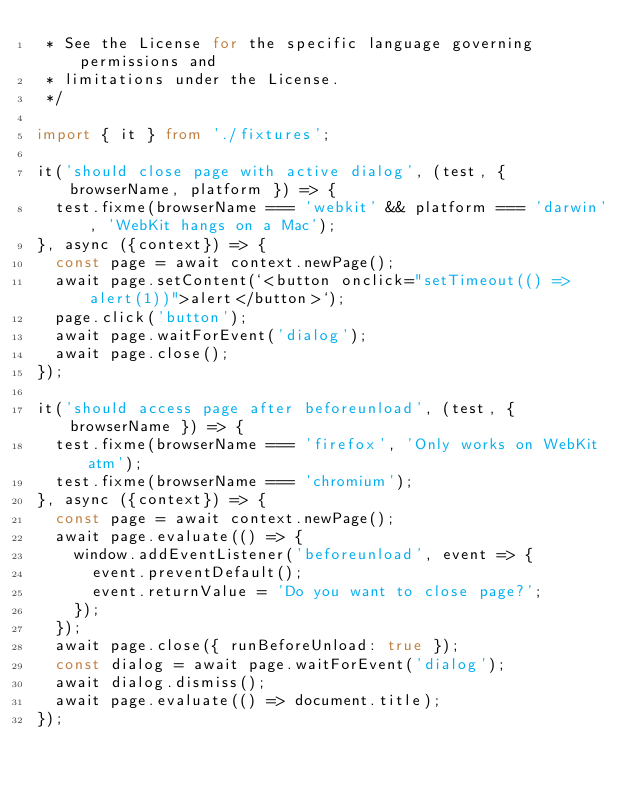Convert code to text. <code><loc_0><loc_0><loc_500><loc_500><_TypeScript_> * See the License for the specific language governing permissions and
 * limitations under the License.
 */

import { it } from './fixtures';

it('should close page with active dialog', (test, { browserName, platform }) => {
  test.fixme(browserName === 'webkit' && platform === 'darwin', 'WebKit hangs on a Mac');
}, async ({context}) => {
  const page = await context.newPage();
  await page.setContent(`<button onclick="setTimeout(() => alert(1))">alert</button>`);
  page.click('button');
  await page.waitForEvent('dialog');
  await page.close();
});

it('should access page after beforeunload', (test, { browserName }) => {
  test.fixme(browserName === 'firefox', 'Only works on WebKit atm');
  test.fixme(browserName === 'chromium');
}, async ({context}) => {
  const page = await context.newPage();
  await page.evaluate(() => {
    window.addEventListener('beforeunload', event => {
      event.preventDefault();
      event.returnValue = 'Do you want to close page?';
    });
  });
  await page.close({ runBeforeUnload: true });
  const dialog = await page.waitForEvent('dialog');
  await dialog.dismiss();
  await page.evaluate(() => document.title);
});
</code> 